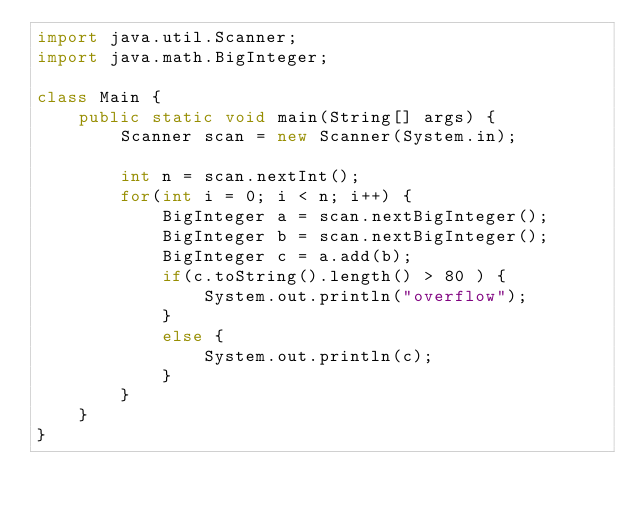<code> <loc_0><loc_0><loc_500><loc_500><_Java_>import java.util.Scanner;
import java.math.BigInteger;

class Main {
	public static void main(String[] args) {
		Scanner scan = new Scanner(System.in);
		
		int n = scan.nextInt();
		for(int i = 0; i < n; i++) {
			BigInteger a = scan.nextBigInteger();
			BigInteger b = scan.nextBigInteger();
			BigInteger c = a.add(b);
			if(c.toString().length() > 80 ) {
				System.out.println("overflow");
			}
			else {
				System.out.println(c);
			}
		}
	}
}</code> 